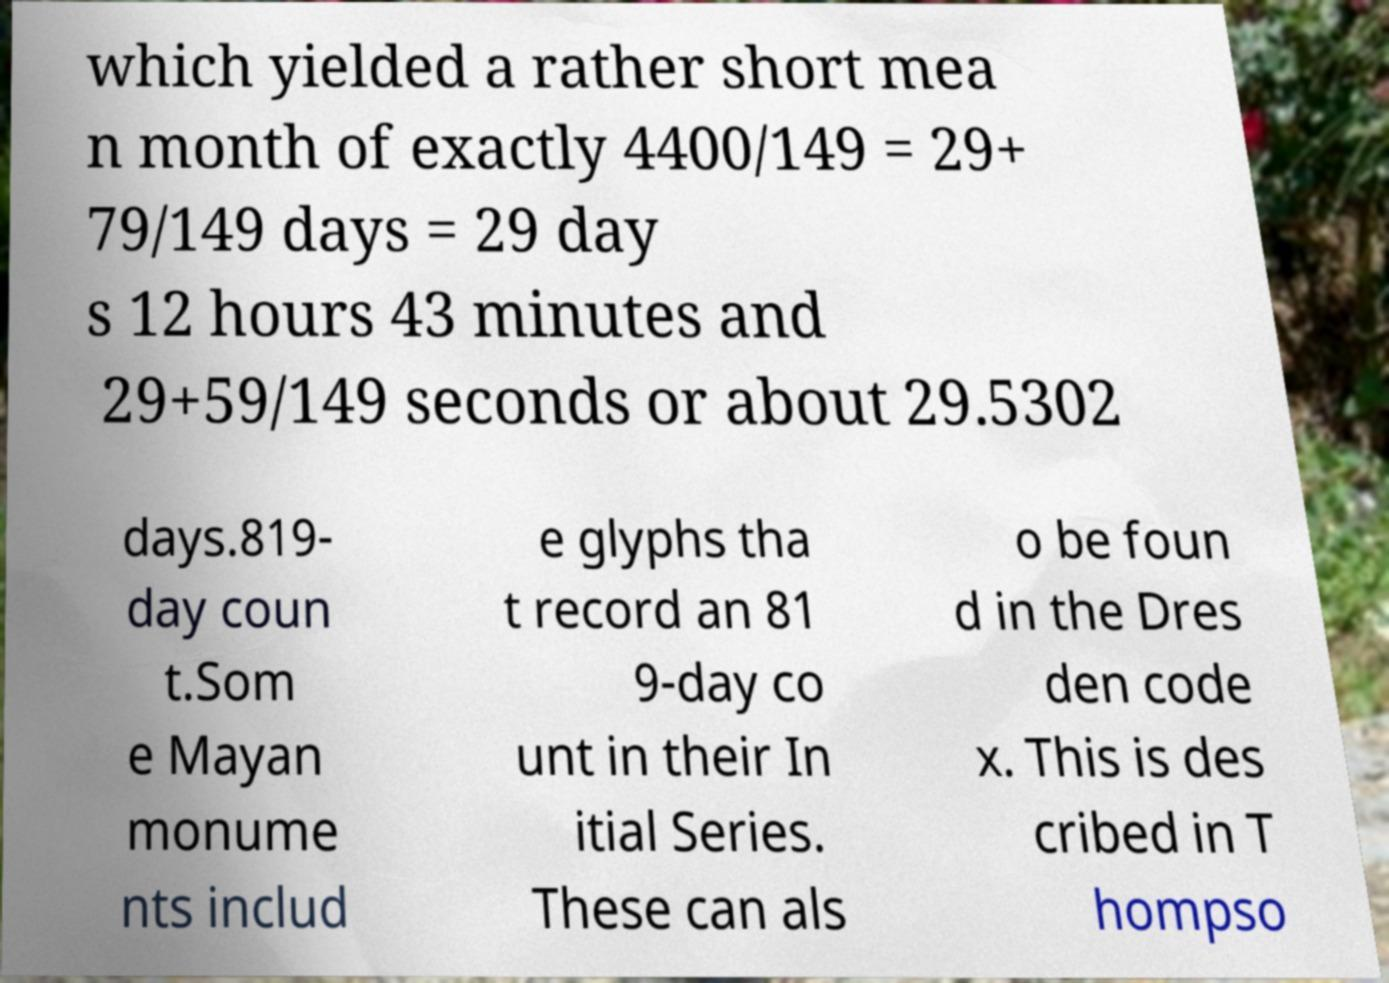Can you accurately transcribe the text from the provided image for me? which yielded a rather short mea n month of exactly 4400/149 = 29+ 79/149 days = 29 day s 12 hours 43 minutes and 29+59/149 seconds or about 29.5302 days.819- day coun t.Som e Mayan monume nts includ e glyphs tha t record an 81 9-day co unt in their In itial Series. These can als o be foun d in the Dres den code x. This is des cribed in T hompso 